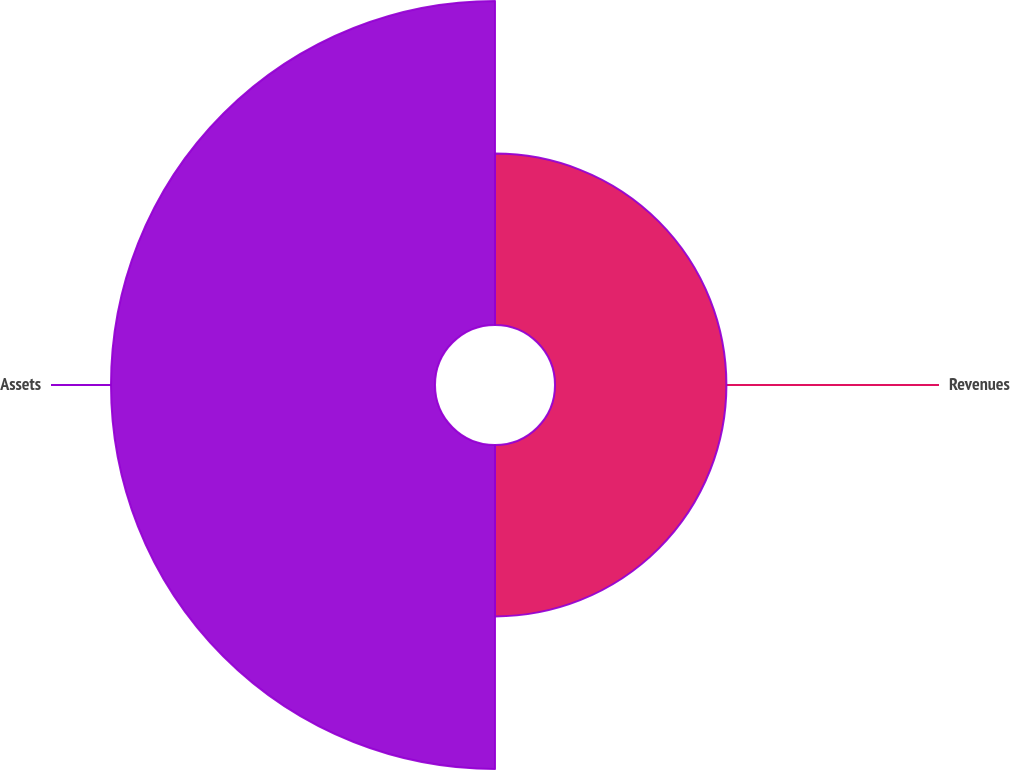Convert chart to OTSL. <chart><loc_0><loc_0><loc_500><loc_500><pie_chart><fcel>Revenues<fcel>Assets<nl><fcel>34.6%<fcel>65.4%<nl></chart> 